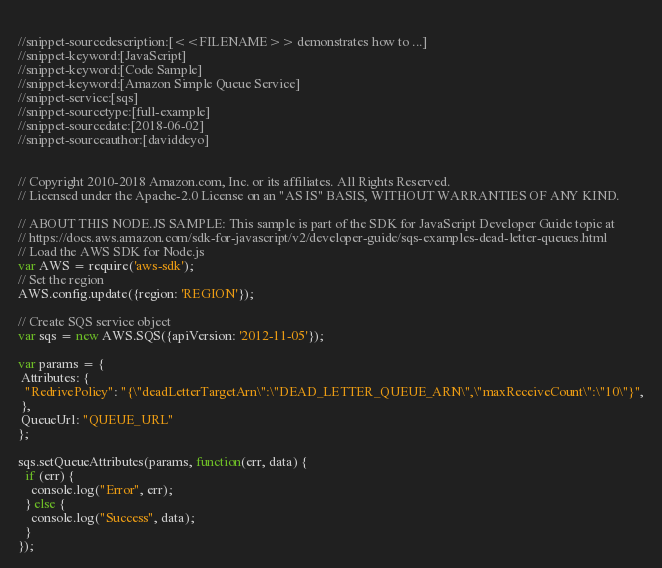Convert code to text. <code><loc_0><loc_0><loc_500><loc_500><_JavaScript_> 
//snippet-sourcedescription:[<<FILENAME>> demonstrates how to ...]
//snippet-keyword:[JavaScript]
//snippet-keyword:[Code Sample]
//snippet-keyword:[Amazon Simple Queue Service]
//snippet-service:[sqs]
//snippet-sourcetype:[full-example]
//snippet-sourcedate:[2018-06-02]
//snippet-sourceauthor:[daviddeyo]


// Copyright 2010-2018 Amazon.com, Inc. or its affiliates. All Rights Reserved.
// Licensed under the Apache-2.0 License on an "AS IS" BASIS, WITHOUT WARRANTIES OF ANY KIND.   

// ABOUT THIS NODE.JS SAMPLE: This sample is part of the SDK for JavaScript Developer Guide topic at
// https://docs.aws.amazon.com/sdk-for-javascript/v2/developer-guide/sqs-examples-dead-letter-queues.html
// Load the AWS SDK for Node.js
var AWS = require('aws-sdk');
// Set the region 
AWS.config.update({region: 'REGION'});

// Create SQS service object
var sqs = new AWS.SQS({apiVersion: '2012-11-05'});

var params = {
 Attributes: {
  "RedrivePolicy": "{\"deadLetterTargetArn\":\"DEAD_LETTER_QUEUE_ARN\",\"maxReceiveCount\":\"10\"}",
 },
 QueueUrl: "QUEUE_URL"
};

sqs.setQueueAttributes(params, function(err, data) {
  if (err) {
    console.log("Error", err);
  } else {
    console.log("Success", data);
  }
});
</code> 